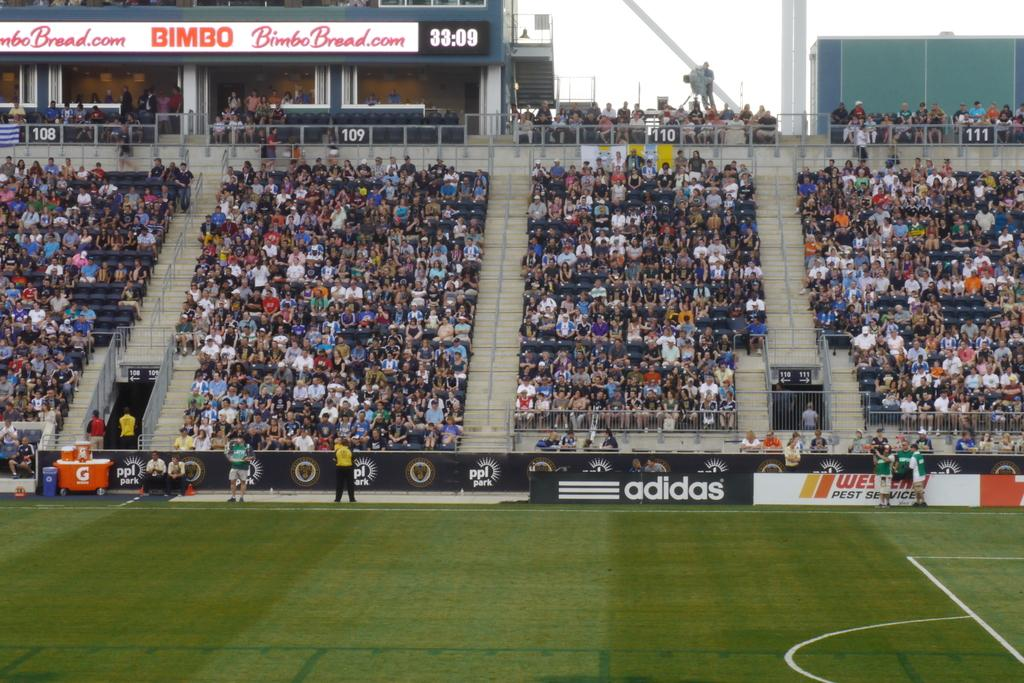<image>
Give a short and clear explanation of the subsequent image. A crowd watches a soccer match amid advertisements for Bimbo bread and adidas 